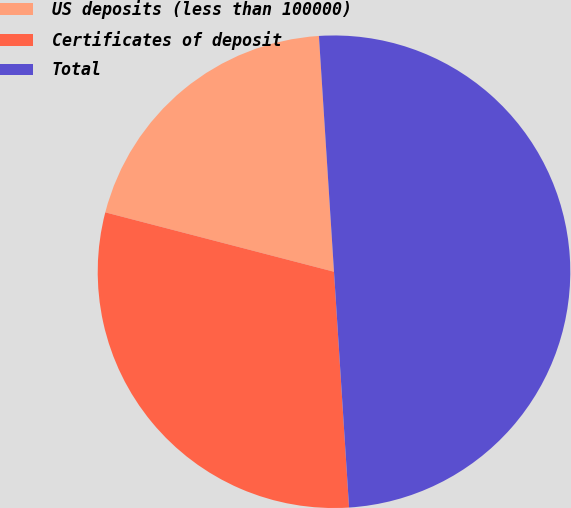<chart> <loc_0><loc_0><loc_500><loc_500><pie_chart><fcel>US deposits (less than 100000)<fcel>Certificates of deposit<fcel>Total<nl><fcel>19.94%<fcel>30.06%<fcel>50.0%<nl></chart> 